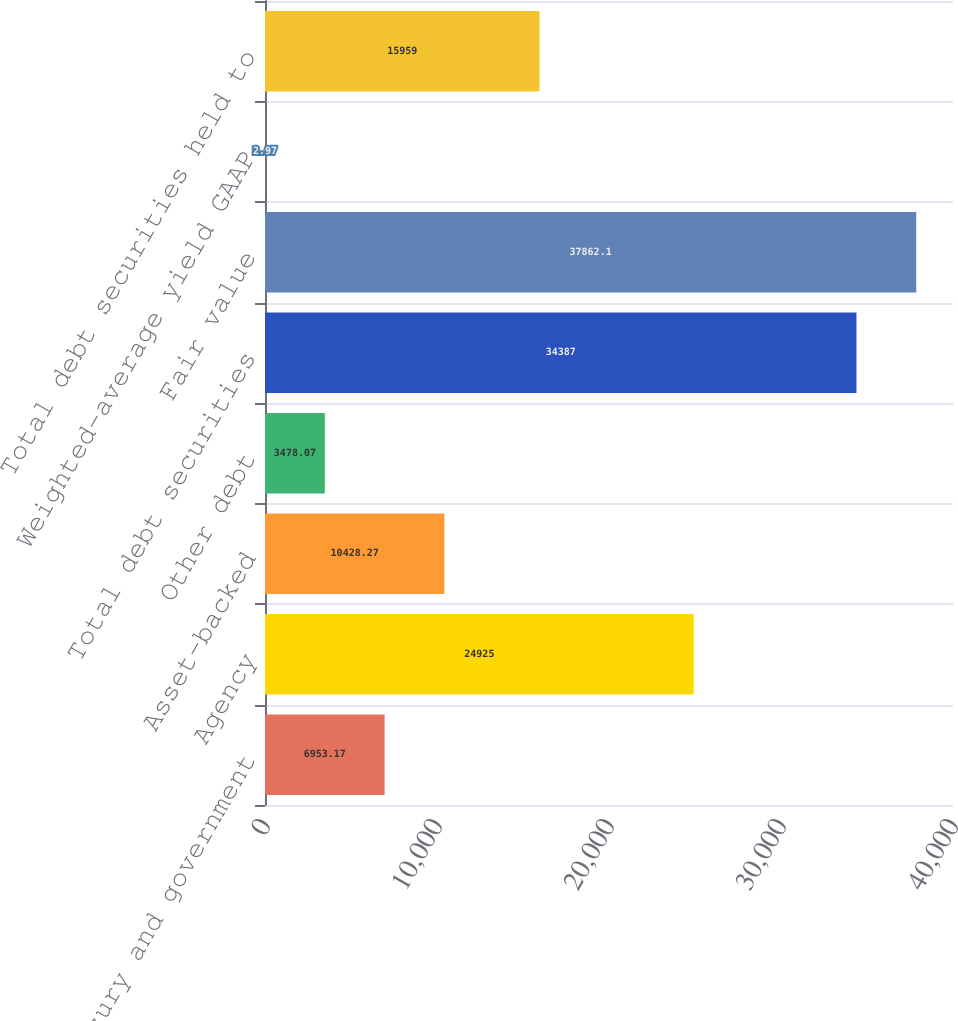Convert chart to OTSL. <chart><loc_0><loc_0><loc_500><loc_500><bar_chart><fcel>US Treasury and government<fcel>Agency<fcel>Asset-backed<fcel>Other debt<fcel>Total debt securities<fcel>Fair value<fcel>Weighted-average yield GAAP<fcel>Total debt securities held to<nl><fcel>6953.17<fcel>24925<fcel>10428.3<fcel>3478.07<fcel>34387<fcel>37862.1<fcel>2.97<fcel>15959<nl></chart> 